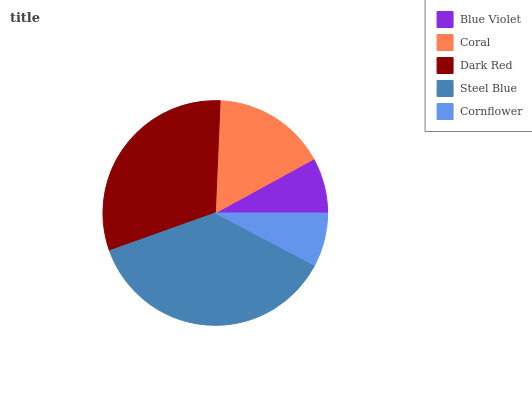Is Cornflower the minimum?
Answer yes or no. Yes. Is Steel Blue the maximum?
Answer yes or no. Yes. Is Coral the minimum?
Answer yes or no. No. Is Coral the maximum?
Answer yes or no. No. Is Coral greater than Blue Violet?
Answer yes or no. Yes. Is Blue Violet less than Coral?
Answer yes or no. Yes. Is Blue Violet greater than Coral?
Answer yes or no. No. Is Coral less than Blue Violet?
Answer yes or no. No. Is Coral the high median?
Answer yes or no. Yes. Is Coral the low median?
Answer yes or no. Yes. Is Steel Blue the high median?
Answer yes or no. No. Is Cornflower the low median?
Answer yes or no. No. 